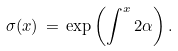Convert formula to latex. <formula><loc_0><loc_0><loc_500><loc_500>\sigma ( x ) \, = \, \exp \left ( \int ^ { x } 2 \alpha \right ) .</formula> 